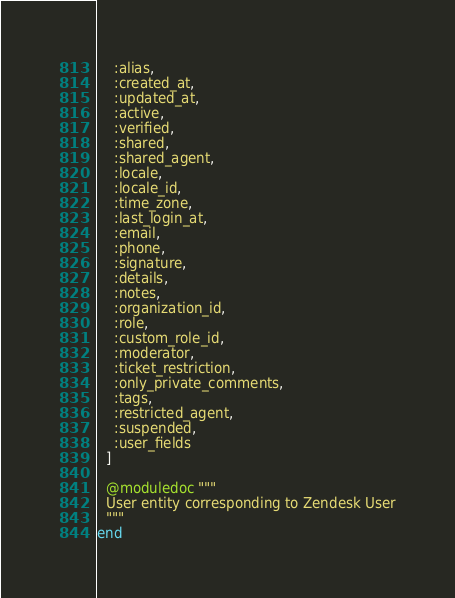<code> <loc_0><loc_0><loc_500><loc_500><_Elixir_>    :alias,
    :created_at,
    :updated_at,
    :active,
    :verified,
    :shared,
    :shared_agent,
    :locale,
    :locale_id,
    :time_zone,
    :last_login_at,
    :email,
    :phone,
    :signature,
    :details,
    :notes,
    :organization_id,
    :role,
    :custom_role_id,
    :moderator,
    :ticket_restriction,
    :only_private_comments,
    :tags,
    :restricted_agent,
    :suspended,
    :user_fields
  ]

  @moduledoc """
  User entity corresponding to Zendesk User
  """
end
</code> 